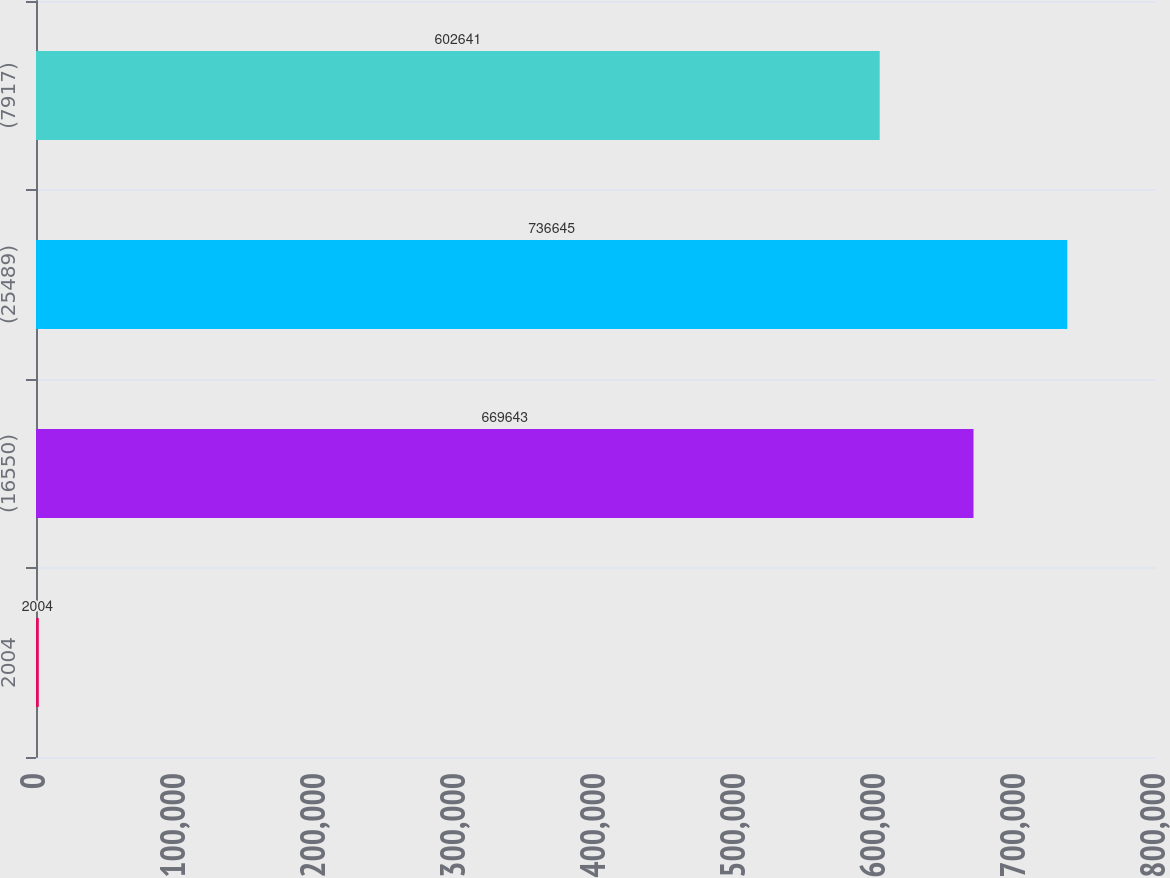Convert chart. <chart><loc_0><loc_0><loc_500><loc_500><bar_chart><fcel>2004<fcel>(16550)<fcel>(25489)<fcel>(7917)<nl><fcel>2004<fcel>669643<fcel>736645<fcel>602641<nl></chart> 